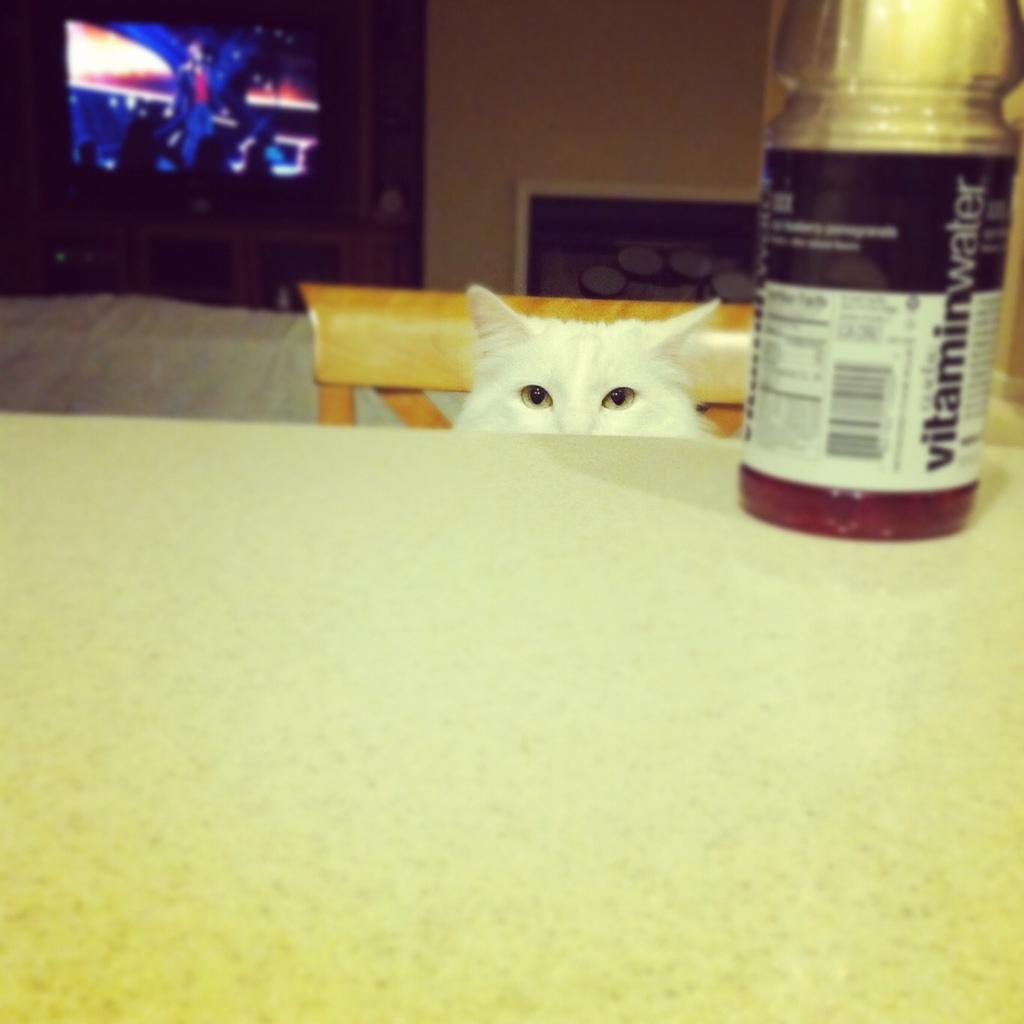What object is on the table in the image? There is a bottle on the table in the image. Where is the cat located in the image? The cat is on a chair behind the table in the image. What type of electronic device is present in the image? There is a TV in the image. How many plants are visible on the table in the image? There are no plants visible on the table in the image. What type of pizza is being served on the TV in the image? There is no pizza present in the image, and the TV is not serving any food. --- Facts: 1. There is a person holding a camera in the image. 2. The person is standing on a bridge. 3. There is a river flowing under the bridge. 4. There are mountains in the background of the image. Absurd Topics: bicycle, umbrella, cake Conversation: What is the person in the image holding? The person in the image is holding a camera. Where is the person standing in the image? The person is standing on a bridge in the image. What can be seen flowing under the bridge? There is a river flowing under the bridge in the image. What type of natural landscape is visible in the background of the image? There are mountains in the background of the image. Reasoning: Let's think step by step in order to produce the conversation. We start by identifying the main subject in the image, which is the person holding a camera. Then, we expand the conversation to include other details about the image, such as the location of the person (on a bridge), the presence of a river flowing under the bridge, and the mountains in the background. Each question is designed to elicit a specific detail about the image that is known from the provided facts. Absurd Question/Answer: How many bicycles are parked on the bridge in the image? There are no bicycles visible on the bridge in the image. What type of cake is being served on the river in the image? There is no cake present in the image, and the river is not serving any food. 